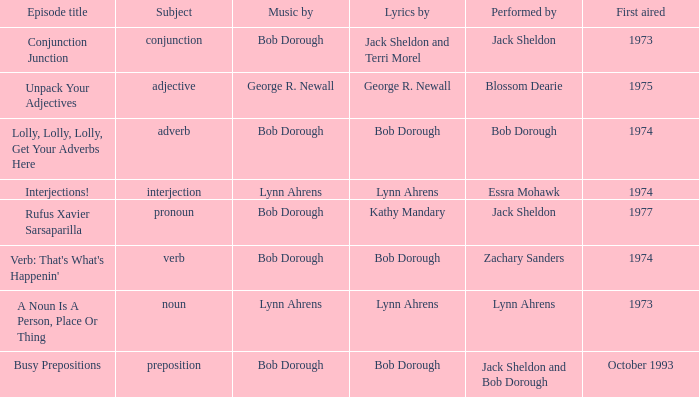When interjection is the subject how many performers are there? 1.0. 